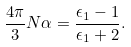<formula> <loc_0><loc_0><loc_500><loc_500>\frac { 4 \pi } { 3 } N \alpha = \frac { \epsilon _ { 1 } - 1 } { \epsilon _ { 1 } + 2 } .</formula> 